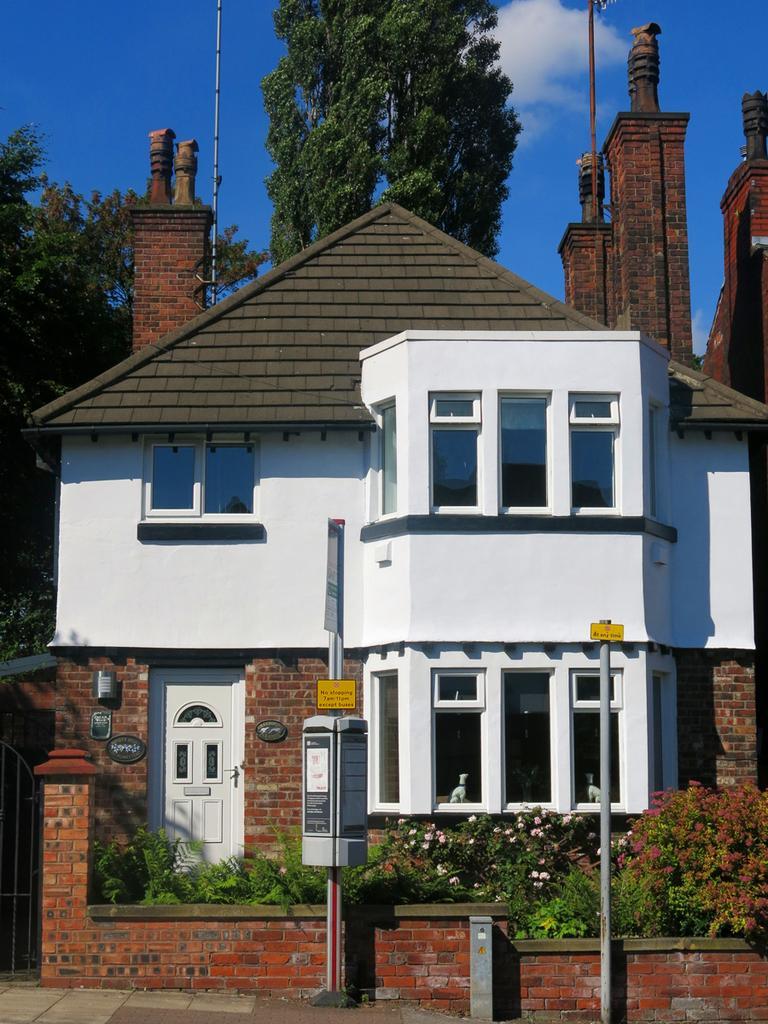How would you summarize this image in a sentence or two? At the bottom, we see the pavement. In front of the picture, we see the poles and the boards in yellow and grey color with some text written on it. Behind that, we see a wall and the plants which have white and red flowers. On the left side, we see a gate. In the middle, we see a building in white color with a grey color roof. There are trees and poles in the background. At the top, we see the clouds and the sky, which is blue in color. 